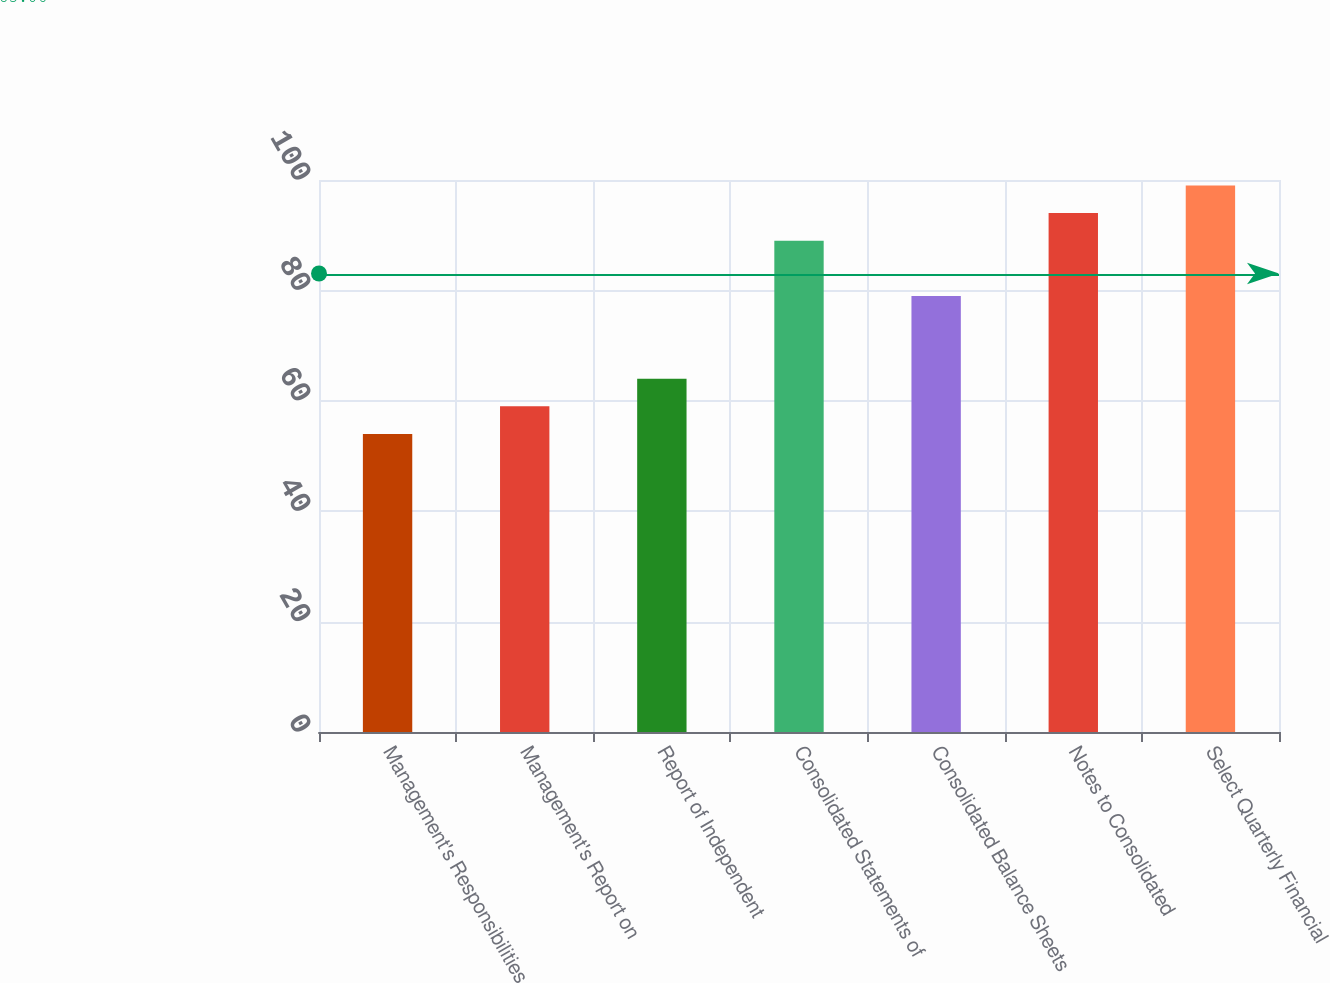<chart> <loc_0><loc_0><loc_500><loc_500><bar_chart><fcel>Management's Responsibilities<fcel>Management's Report on<fcel>Report of Independent<fcel>Consolidated Statements of<fcel>Consolidated Balance Sheets<fcel>Notes to Consolidated<fcel>Select Quarterly Financial<nl><fcel>54<fcel>59<fcel>64<fcel>89<fcel>79<fcel>94<fcel>99<nl></chart> 